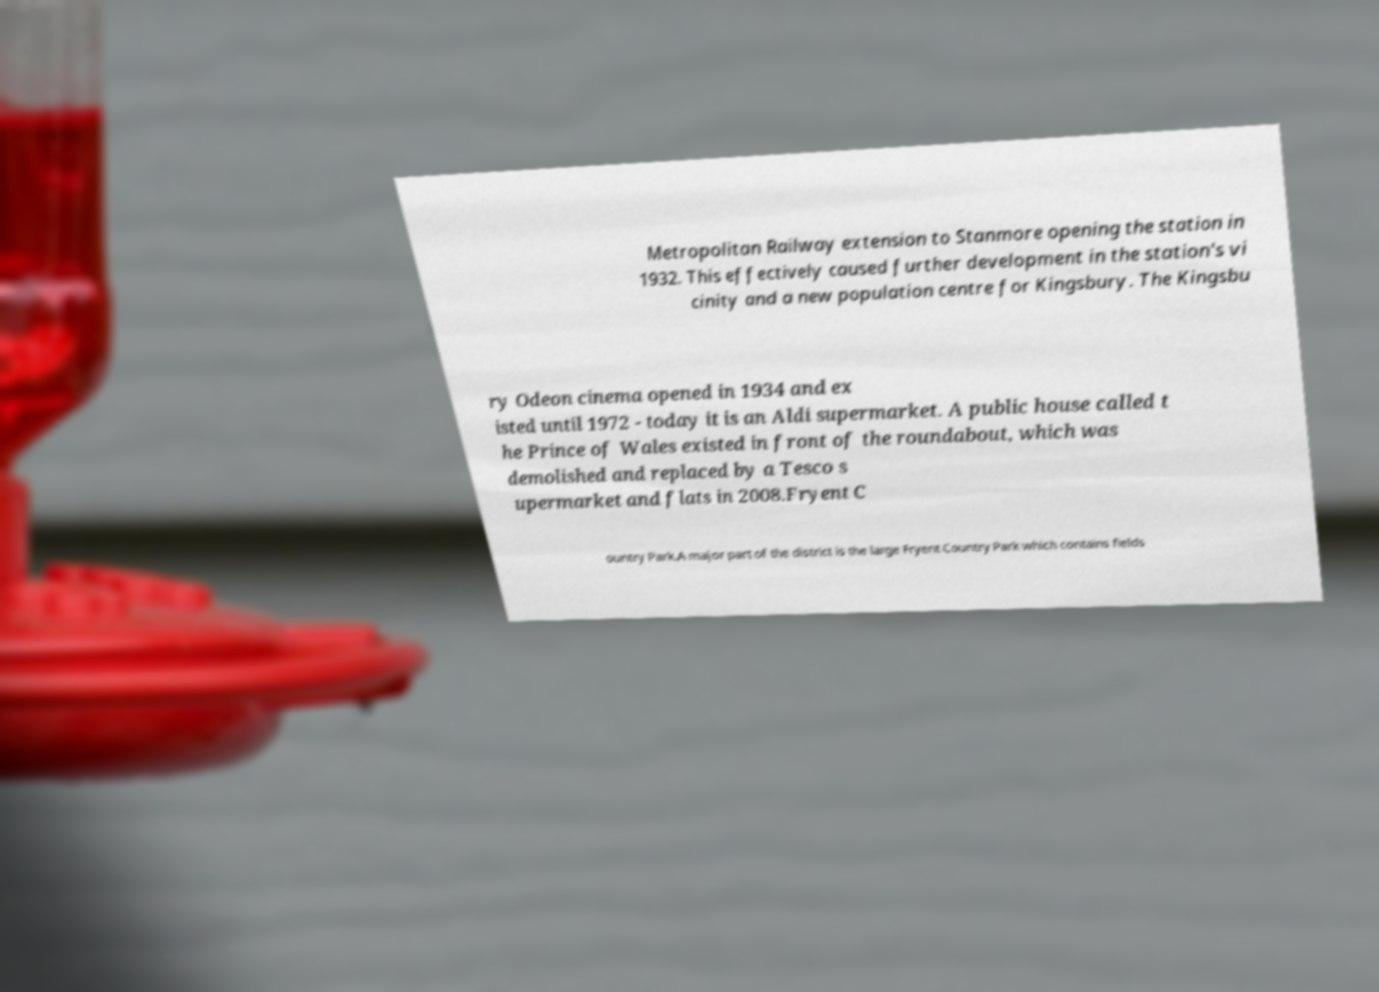Could you assist in decoding the text presented in this image and type it out clearly? Metropolitan Railway extension to Stanmore opening the station in 1932. This effectively caused further development in the station's vi cinity and a new population centre for Kingsbury. The Kingsbu ry Odeon cinema opened in 1934 and ex isted until 1972 - today it is an Aldi supermarket. A public house called t he Prince of Wales existed in front of the roundabout, which was demolished and replaced by a Tesco s upermarket and flats in 2008.Fryent C ountry Park.A major part of the district is the large Fryent Country Park which contains fields 